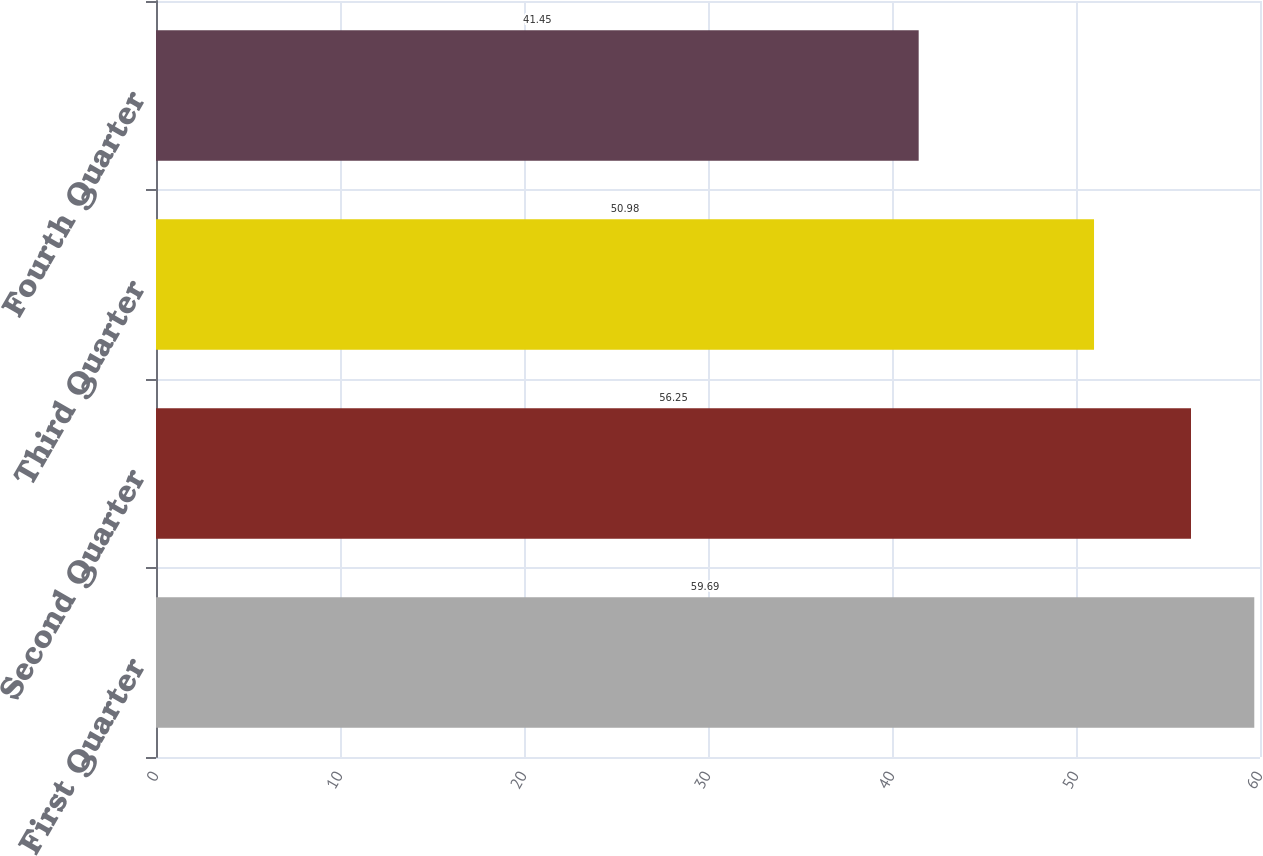<chart> <loc_0><loc_0><loc_500><loc_500><bar_chart><fcel>First Quarter<fcel>Second Quarter<fcel>Third Quarter<fcel>Fourth Quarter<nl><fcel>59.69<fcel>56.25<fcel>50.98<fcel>41.45<nl></chart> 